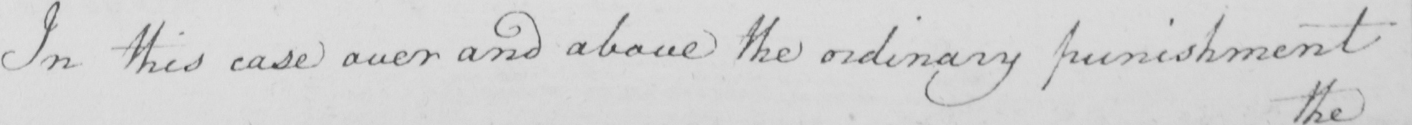Please provide the text content of this handwritten line. In this case over and above the ordinary punishment 